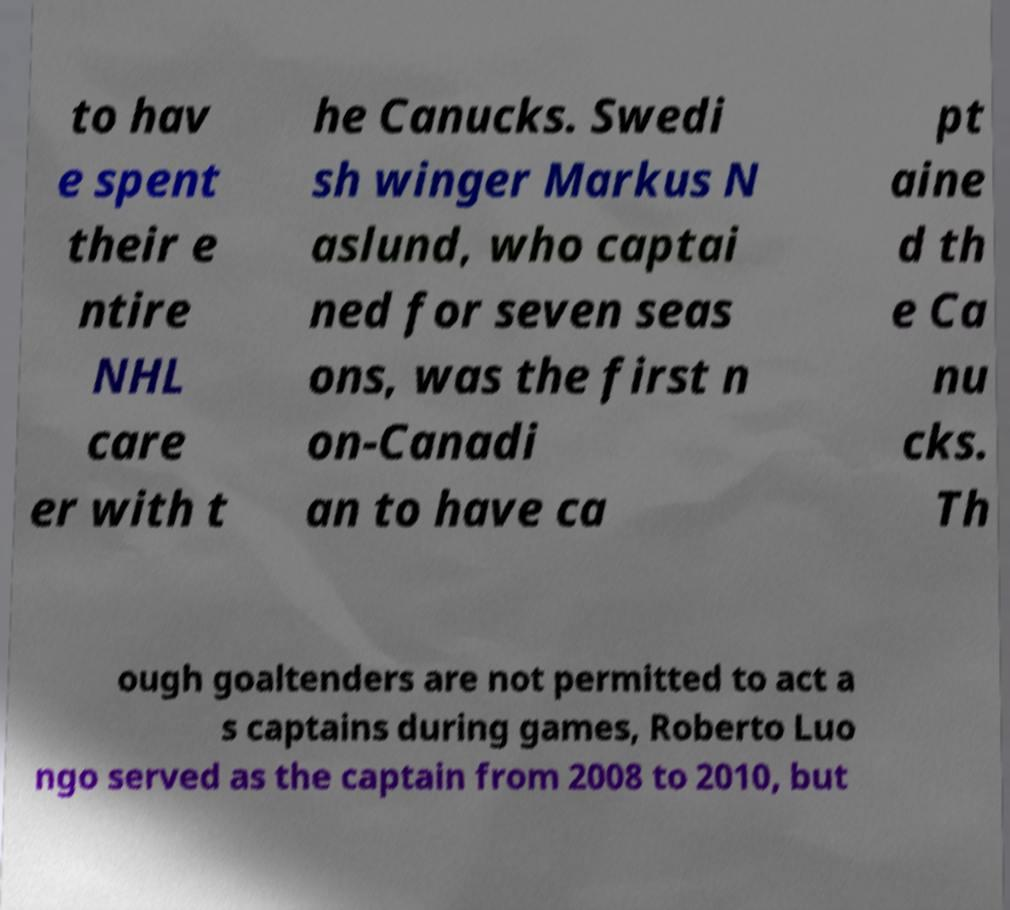Could you assist in decoding the text presented in this image and type it out clearly? to hav e spent their e ntire NHL care er with t he Canucks. Swedi sh winger Markus N aslund, who captai ned for seven seas ons, was the first n on-Canadi an to have ca pt aine d th e Ca nu cks. Th ough goaltenders are not permitted to act a s captains during games, Roberto Luo ngo served as the captain from 2008 to 2010, but 